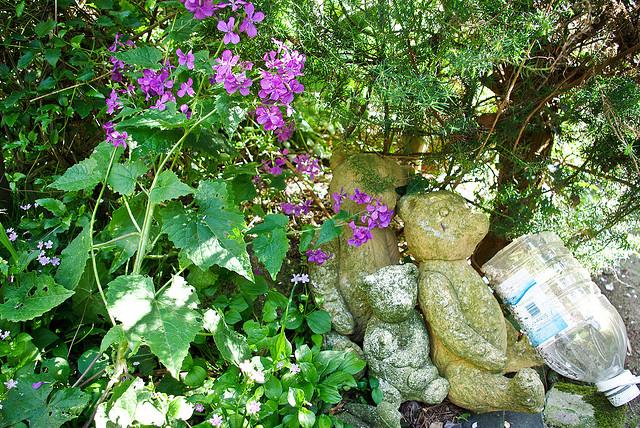Are those flowers?
Write a very short answer. Yes. What type of plant is this?
Keep it brief. Flower. Is that a branch full of fruit?
Concise answer only. No. What are the bears made out of?
Write a very short answer. Stone. What is laying beside the bears?
Write a very short answer. Bottle. Where are the lilies?
Be succinct. Garden. What color are the flowers?
Write a very short answer. Purple. 